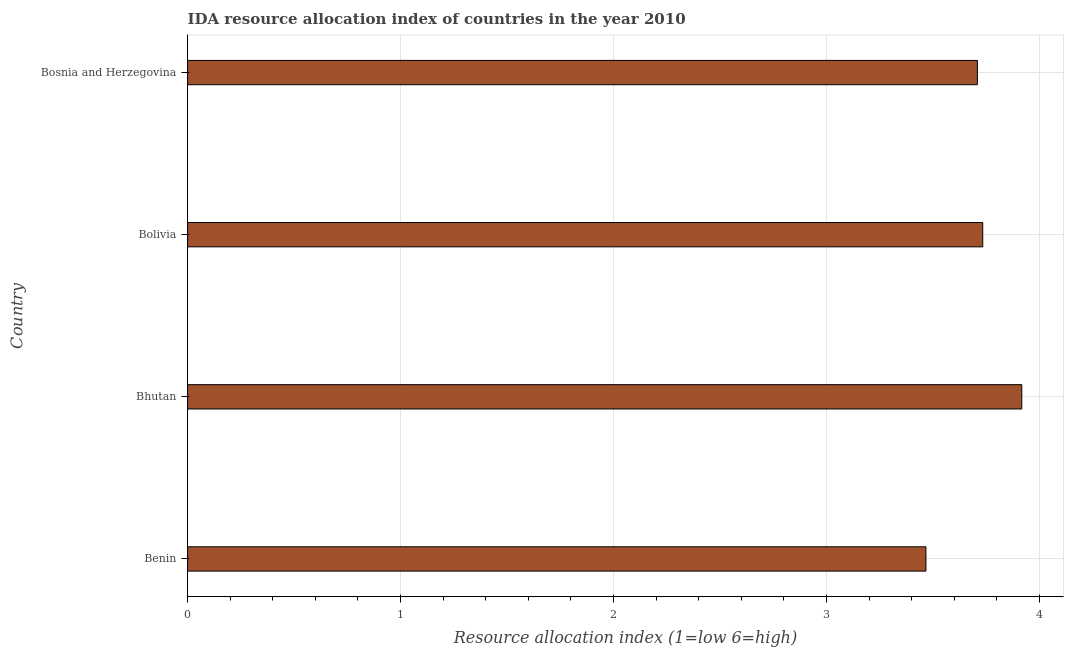What is the title of the graph?
Your response must be concise. IDA resource allocation index of countries in the year 2010. What is the label or title of the X-axis?
Give a very brief answer. Resource allocation index (1=low 6=high). What is the label or title of the Y-axis?
Make the answer very short. Country. What is the ida resource allocation index in Bolivia?
Your answer should be very brief. 3.73. Across all countries, what is the maximum ida resource allocation index?
Offer a very short reply. 3.92. Across all countries, what is the minimum ida resource allocation index?
Provide a short and direct response. 3.47. In which country was the ida resource allocation index maximum?
Keep it short and to the point. Bhutan. In which country was the ida resource allocation index minimum?
Make the answer very short. Benin. What is the sum of the ida resource allocation index?
Keep it short and to the point. 14.82. What is the difference between the ida resource allocation index in Benin and Bosnia and Herzegovina?
Keep it short and to the point. -0.24. What is the average ida resource allocation index per country?
Keep it short and to the point. 3.71. What is the median ida resource allocation index?
Provide a short and direct response. 3.72. What is the ratio of the ida resource allocation index in Bhutan to that in Bosnia and Herzegovina?
Keep it short and to the point. 1.06. What is the difference between the highest and the second highest ida resource allocation index?
Provide a short and direct response. 0.18. What is the difference between the highest and the lowest ida resource allocation index?
Keep it short and to the point. 0.45. In how many countries, is the ida resource allocation index greater than the average ida resource allocation index taken over all countries?
Offer a very short reply. 3. Are all the bars in the graph horizontal?
Your response must be concise. Yes. Are the values on the major ticks of X-axis written in scientific E-notation?
Ensure brevity in your answer.  No. What is the Resource allocation index (1=low 6=high) of Benin?
Keep it short and to the point. 3.47. What is the Resource allocation index (1=low 6=high) in Bhutan?
Keep it short and to the point. 3.92. What is the Resource allocation index (1=low 6=high) in Bolivia?
Offer a terse response. 3.73. What is the Resource allocation index (1=low 6=high) of Bosnia and Herzegovina?
Keep it short and to the point. 3.71. What is the difference between the Resource allocation index (1=low 6=high) in Benin and Bhutan?
Offer a very short reply. -0.45. What is the difference between the Resource allocation index (1=low 6=high) in Benin and Bolivia?
Give a very brief answer. -0.27. What is the difference between the Resource allocation index (1=low 6=high) in Benin and Bosnia and Herzegovina?
Provide a succinct answer. -0.24. What is the difference between the Resource allocation index (1=low 6=high) in Bhutan and Bolivia?
Your answer should be very brief. 0.18. What is the difference between the Resource allocation index (1=low 6=high) in Bhutan and Bosnia and Herzegovina?
Your answer should be very brief. 0.21. What is the difference between the Resource allocation index (1=low 6=high) in Bolivia and Bosnia and Herzegovina?
Offer a very short reply. 0.03. What is the ratio of the Resource allocation index (1=low 6=high) in Benin to that in Bhutan?
Offer a very short reply. 0.89. What is the ratio of the Resource allocation index (1=low 6=high) in Benin to that in Bolivia?
Offer a terse response. 0.93. What is the ratio of the Resource allocation index (1=low 6=high) in Benin to that in Bosnia and Herzegovina?
Keep it short and to the point. 0.94. What is the ratio of the Resource allocation index (1=low 6=high) in Bhutan to that in Bolivia?
Give a very brief answer. 1.05. What is the ratio of the Resource allocation index (1=low 6=high) in Bhutan to that in Bosnia and Herzegovina?
Give a very brief answer. 1.06. 